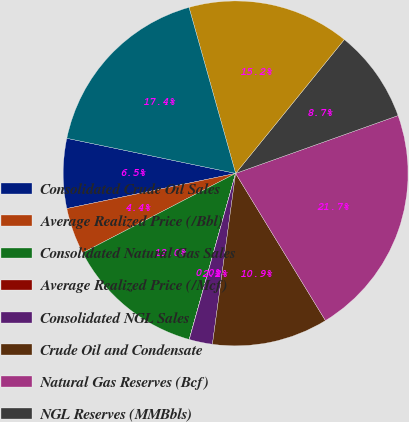Convert chart to OTSL. <chart><loc_0><loc_0><loc_500><loc_500><pie_chart><fcel>Consolidated Crude Oil Sales<fcel>Average Realized Price (/Bbl)<fcel>Consolidated Natural Gas Sales<fcel>Average Realized Price (/Mcf)<fcel>Consolidated NGL Sales<fcel>Crude Oil and Condensate<fcel>Natural Gas Reserves (Bcf)<fcel>NGL Reserves (MMBbls)<fcel>Total Reserves (MMBoe)<fcel>Number of Employees<nl><fcel>6.53%<fcel>4.35%<fcel>13.04%<fcel>0.01%<fcel>2.18%<fcel>10.87%<fcel>21.72%<fcel>8.7%<fcel>15.21%<fcel>17.38%<nl></chart> 